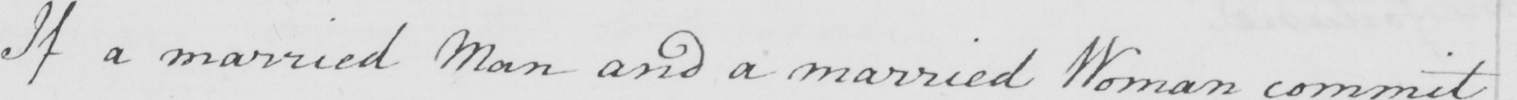Can you read and transcribe this handwriting? If a married Man and a married Woman commit 